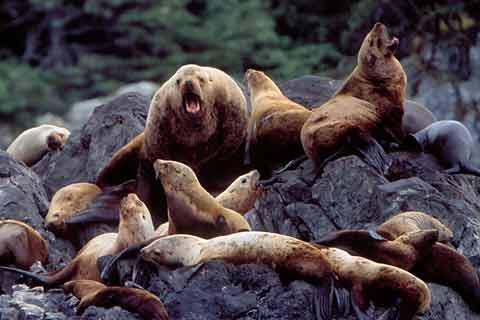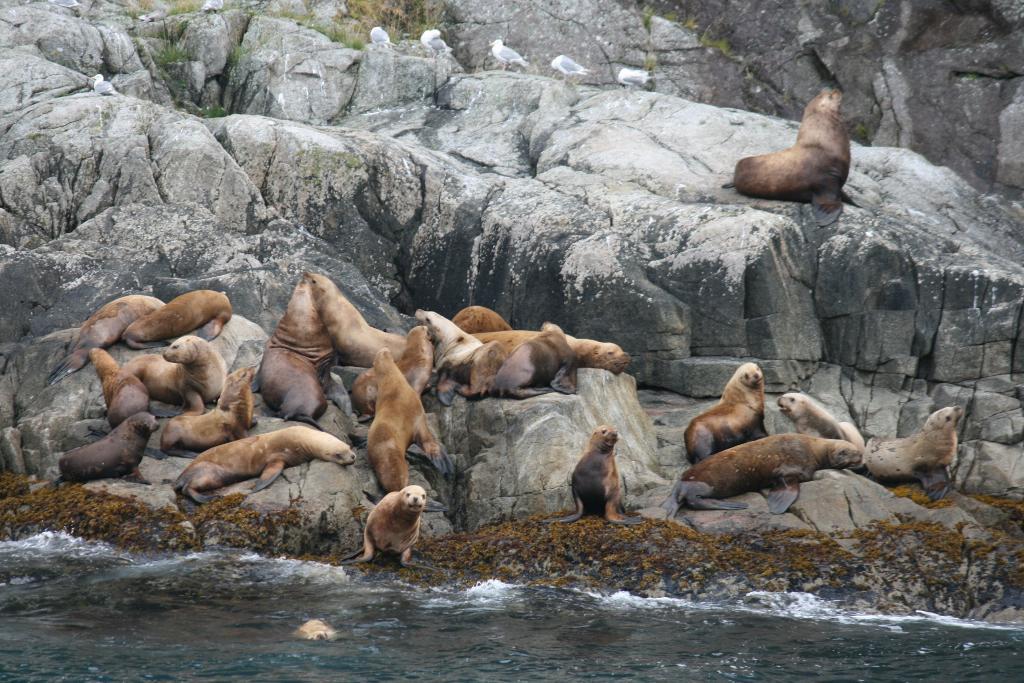The first image is the image on the left, the second image is the image on the right. Considering the images on both sides, is "One of the seals has his mouth open in the left image." valid? Answer yes or no. Yes. The first image is the image on the left, the second image is the image on the right. For the images shown, is this caption "At least one seal is showing its teeth." true? Answer yes or no. Yes. 